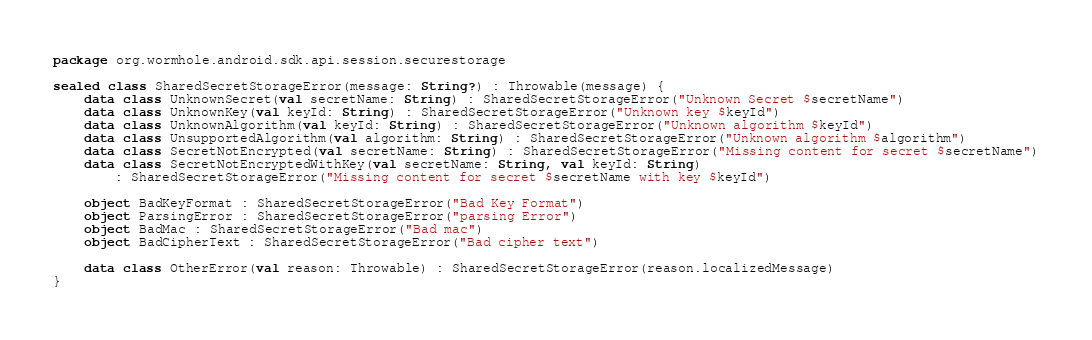Convert code to text. <code><loc_0><loc_0><loc_500><loc_500><_Kotlin_>package org.wormhole.android.sdk.api.session.securestorage

sealed class SharedSecretStorageError(message: String?) : Throwable(message) {
    data class UnknownSecret(val secretName: String) : SharedSecretStorageError("Unknown Secret $secretName")
    data class UnknownKey(val keyId: String) : SharedSecretStorageError("Unknown key $keyId")
    data class UnknownAlgorithm(val keyId: String) : SharedSecretStorageError("Unknown algorithm $keyId")
    data class UnsupportedAlgorithm(val algorithm: String) : SharedSecretStorageError("Unknown algorithm $algorithm")
    data class SecretNotEncrypted(val secretName: String) : SharedSecretStorageError("Missing content for secret $secretName")
    data class SecretNotEncryptedWithKey(val secretName: String, val keyId: String)
        : SharedSecretStorageError("Missing content for secret $secretName with key $keyId")

    object BadKeyFormat : SharedSecretStorageError("Bad Key Format")
    object ParsingError : SharedSecretStorageError("parsing Error")
    object BadMac : SharedSecretStorageError("Bad mac")
    object BadCipherText : SharedSecretStorageError("Bad cipher text")

    data class OtherError(val reason: Throwable) : SharedSecretStorageError(reason.localizedMessage)
}
</code> 